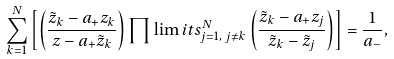<formula> <loc_0><loc_0><loc_500><loc_500>\sum _ { k = 1 } ^ { N } \left [ \left ( \frac { \tilde { z } _ { k } - a _ { + } z _ { k } } { z - a _ { + } \tilde { z } _ { k } } \right ) \prod \lim i t s _ { j = 1 , \, j \neq k } ^ { N } \left ( \frac { \tilde { z } _ { k } - a _ { + } z _ { j } } { \tilde { z } _ { k } - \tilde { z } _ { j } } \right ) \right ] = \frac { 1 } { a _ { - } } ,</formula> 